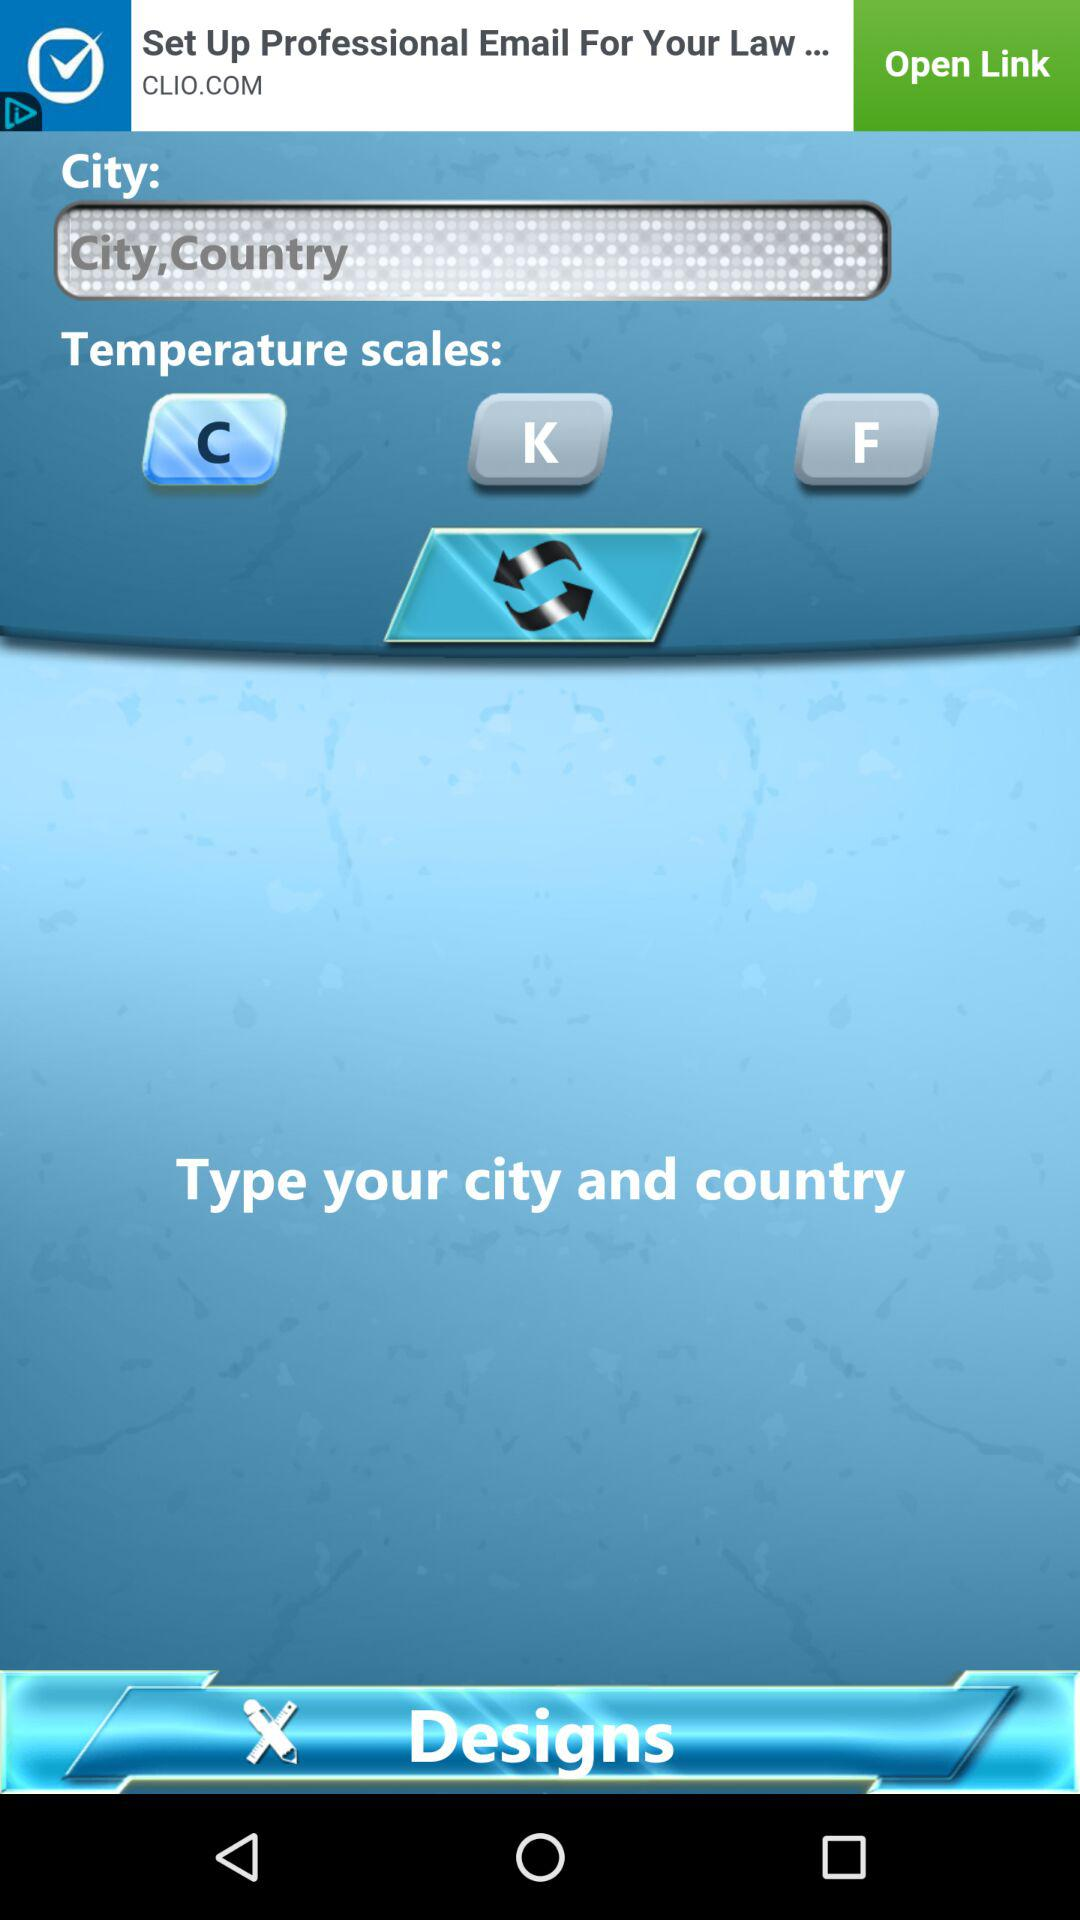Which city was typed in?
When the provided information is insufficient, respond with <no answer>. <no answer> 